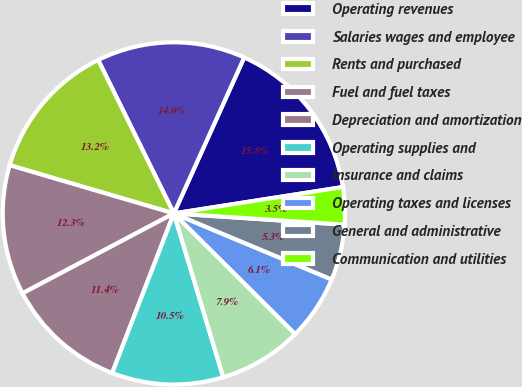<chart> <loc_0><loc_0><loc_500><loc_500><pie_chart><fcel>Operating revenues<fcel>Salaries wages and employee<fcel>Rents and purchased<fcel>Fuel and fuel taxes<fcel>Depreciation and amortization<fcel>Operating supplies and<fcel>Insurance and claims<fcel>Operating taxes and licenses<fcel>General and administrative<fcel>Communication and utilities<nl><fcel>15.79%<fcel>14.04%<fcel>13.16%<fcel>12.28%<fcel>11.4%<fcel>10.53%<fcel>7.89%<fcel>6.14%<fcel>5.26%<fcel>3.51%<nl></chart> 